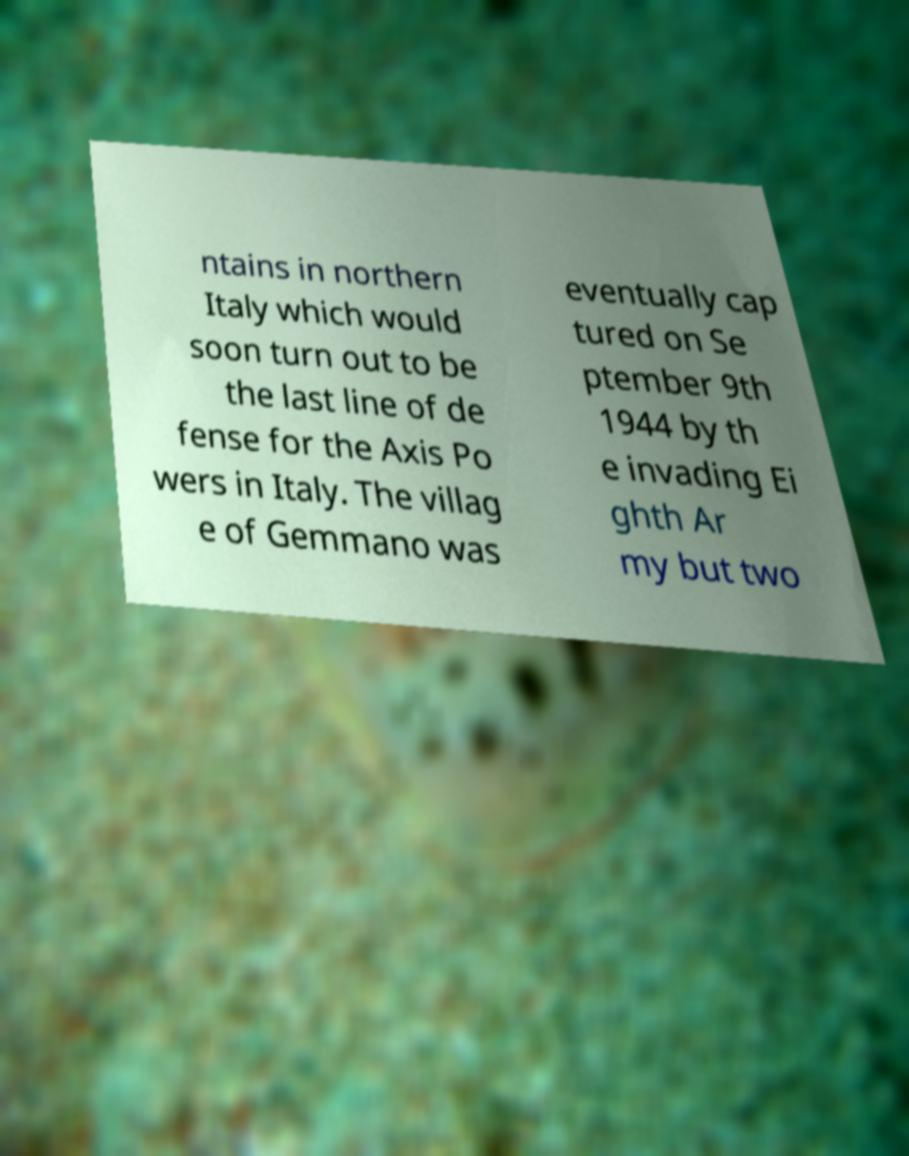Could you assist in decoding the text presented in this image and type it out clearly? ntains in northern Italy which would soon turn out to be the last line of de fense for the Axis Po wers in Italy. The villag e of Gemmano was eventually cap tured on Se ptember 9th 1944 by th e invading Ei ghth Ar my but two 